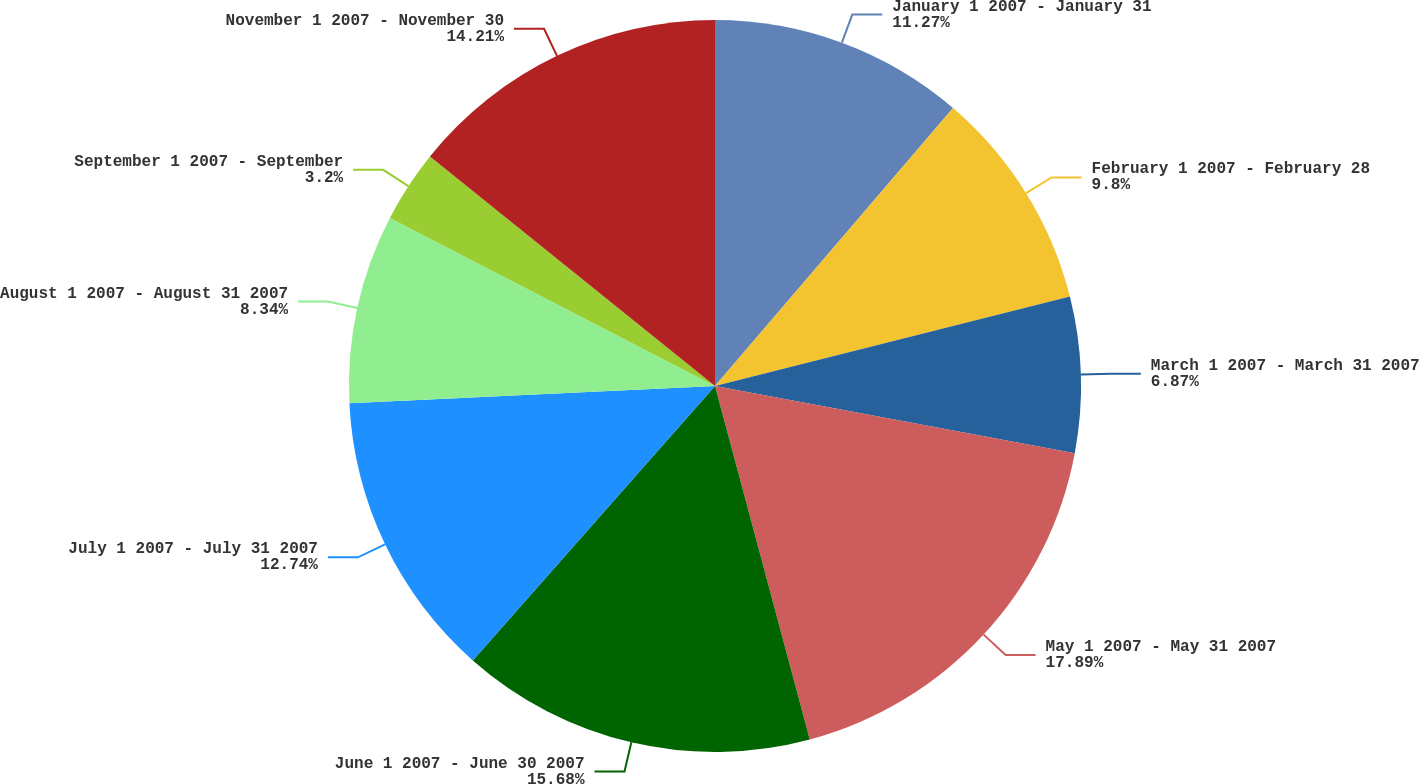<chart> <loc_0><loc_0><loc_500><loc_500><pie_chart><fcel>January 1 2007 - January 31<fcel>February 1 2007 - February 28<fcel>March 1 2007 - March 31 2007<fcel>May 1 2007 - May 31 2007<fcel>June 1 2007 - June 30 2007<fcel>July 1 2007 - July 31 2007<fcel>August 1 2007 - August 31 2007<fcel>September 1 2007 - September<fcel>November 1 2007 - November 30<nl><fcel>11.27%<fcel>9.8%<fcel>6.87%<fcel>17.89%<fcel>15.68%<fcel>12.74%<fcel>8.34%<fcel>3.2%<fcel>14.21%<nl></chart> 